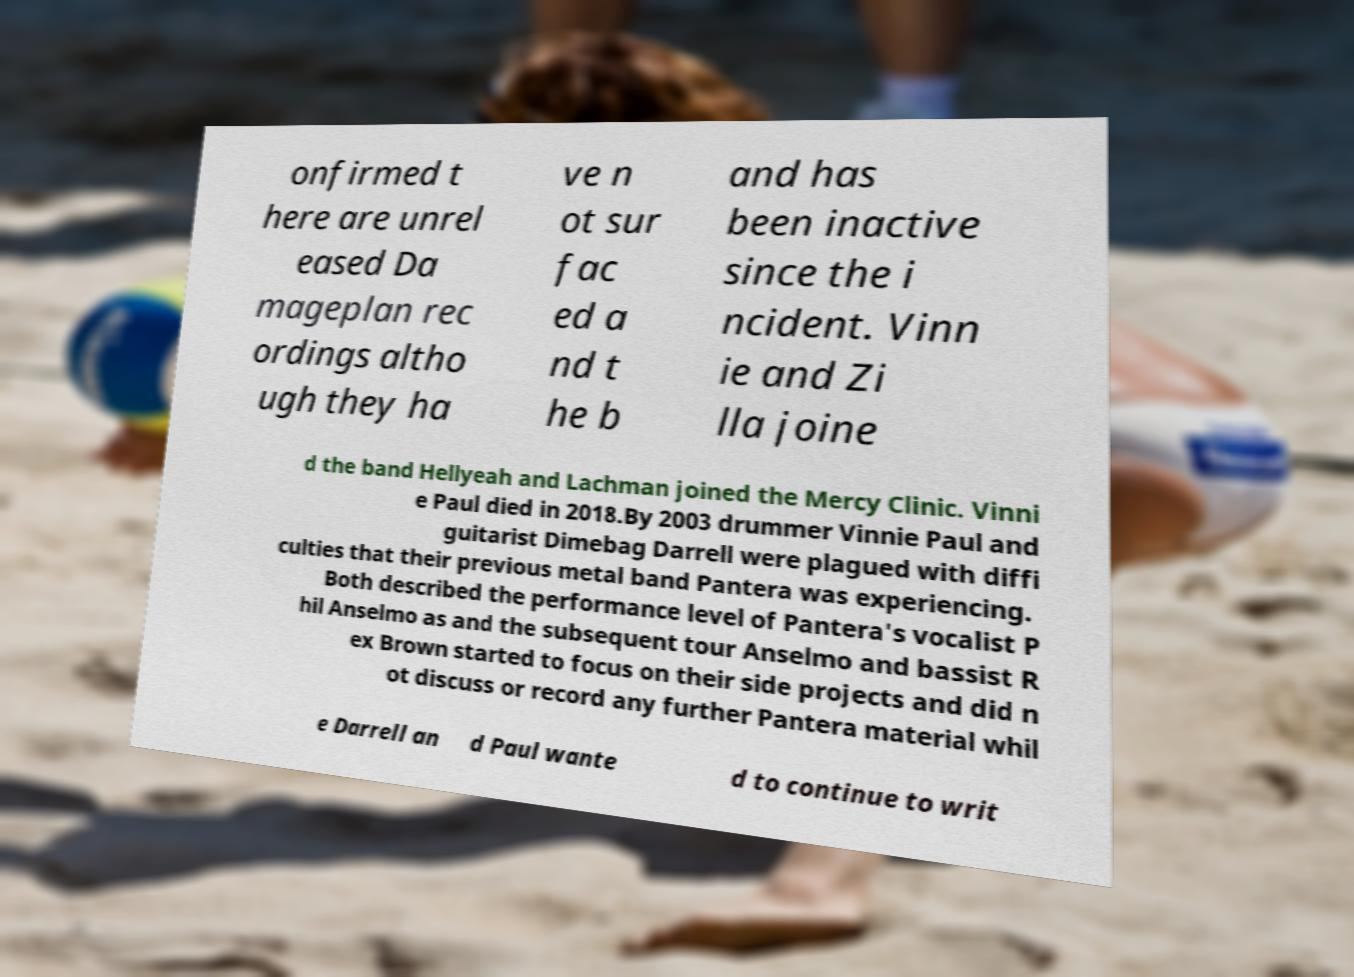There's text embedded in this image that I need extracted. Can you transcribe it verbatim? onfirmed t here are unrel eased Da mageplan rec ordings altho ugh they ha ve n ot sur fac ed a nd t he b and has been inactive since the i ncident. Vinn ie and Zi lla joine d the band Hellyeah and Lachman joined the Mercy Clinic. Vinni e Paul died in 2018.By 2003 drummer Vinnie Paul and guitarist Dimebag Darrell were plagued with diffi culties that their previous metal band Pantera was experiencing. Both described the performance level of Pantera's vocalist P hil Anselmo as and the subsequent tour Anselmo and bassist R ex Brown started to focus on their side projects and did n ot discuss or record any further Pantera material whil e Darrell an d Paul wante d to continue to writ 